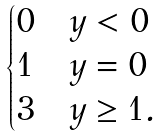<formula> <loc_0><loc_0><loc_500><loc_500>\begin{cases} 0 & y < 0 \\ 1 & y = 0 \\ 3 & y \geq 1 . \\ \end{cases}</formula> 